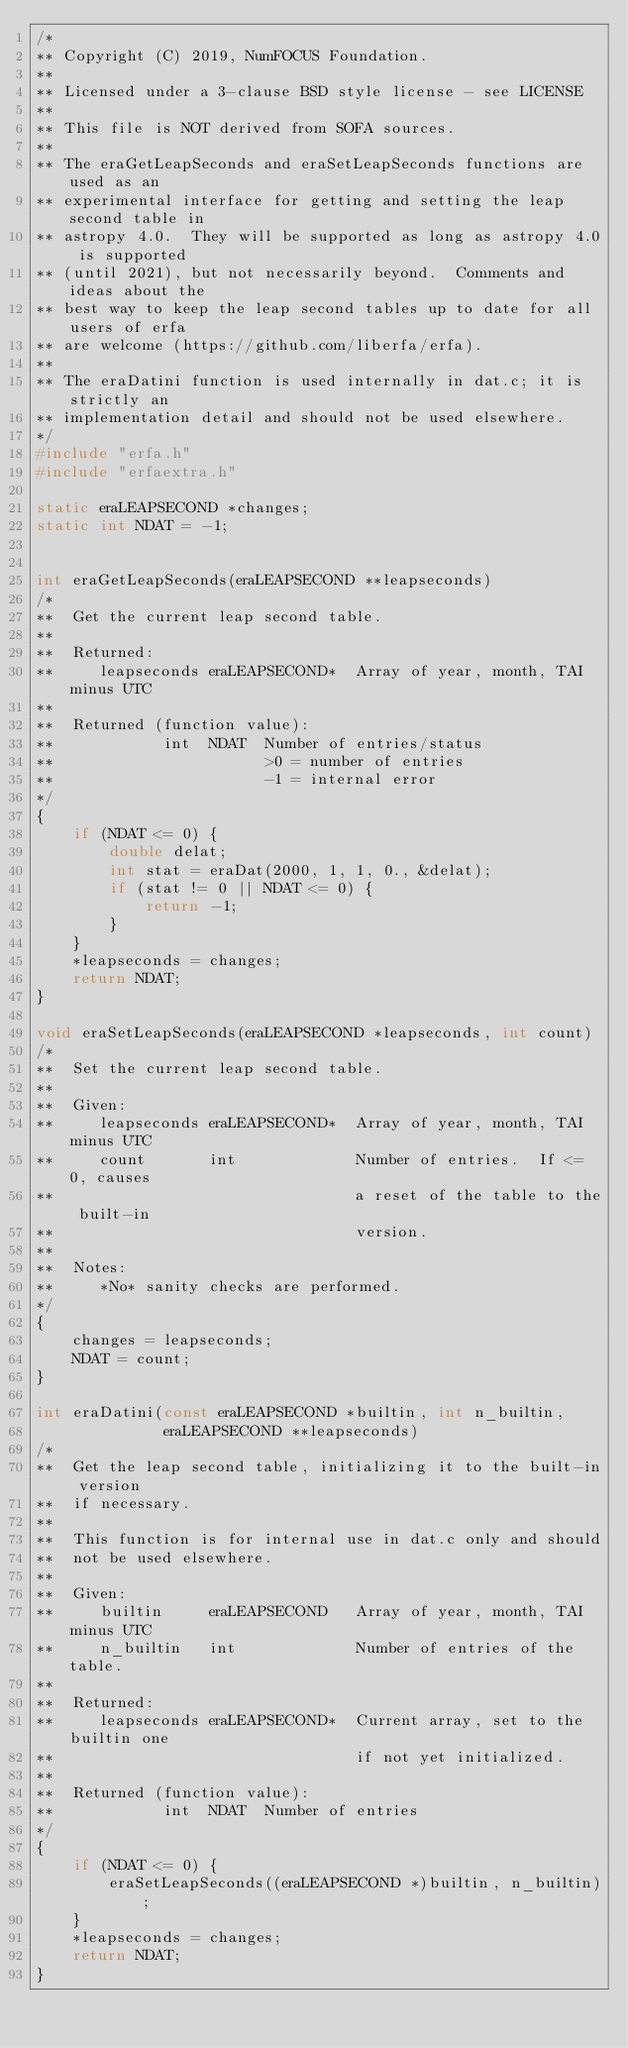Convert code to text. <code><loc_0><loc_0><loc_500><loc_500><_C_>/*
** Copyright (C) 2019, NumFOCUS Foundation.
**
** Licensed under a 3-clause BSD style license - see LICENSE
**
** This file is NOT derived from SOFA sources.
**
** The eraGetLeapSeconds and eraSetLeapSeconds functions are used as an
** experimental interface for getting and setting the leap second table in
** astropy 4.0.  They will be supported as long as astropy 4.0 is supported
** (until 2021), but not necessarily beyond.  Comments and ideas about the
** best way to keep the leap second tables up to date for all users of erfa
** are welcome (https://github.com/liberfa/erfa).
**
** The eraDatini function is used internally in dat.c; it is strictly an
** implementation detail and should not be used elsewhere.
*/
#include "erfa.h"
#include "erfaextra.h"

static eraLEAPSECOND *changes;
static int NDAT = -1;


int eraGetLeapSeconds(eraLEAPSECOND **leapseconds)
/*
**  Get the current leap second table.
**
**  Returned:
**     leapseconds eraLEAPSECOND*  Array of year, month, TAI minus UTC
**
**  Returned (function value):
**            int  NDAT  Number of entries/status
**                       >0 = number of entries
**                       -1 = internal error
*/
{
    if (NDAT <= 0) {
        double delat;
        int stat = eraDat(2000, 1, 1, 0., &delat);
        if (stat != 0 || NDAT <= 0) {
            return -1;
        }
    }
    *leapseconds = changes;
    return NDAT;
}

void eraSetLeapSeconds(eraLEAPSECOND *leapseconds, int count)
/*
**  Set the current leap second table.
**
**  Given:
**     leapseconds eraLEAPSECOND*  Array of year, month, TAI minus UTC
**     count       int             Number of entries.  If <= 0, causes
**                                 a reset of the table to the built-in
**                                 version.
**
**  Notes:
**     *No* sanity checks are performed.
*/
{
    changes = leapseconds;
    NDAT = count;
}

int eraDatini(const eraLEAPSECOND *builtin, int n_builtin,
              eraLEAPSECOND **leapseconds)
/*
**  Get the leap second table, initializing it to the built-in version
**  if necessary.
**
**  This function is for internal use in dat.c only and should
**  not be used elsewhere.
**
**  Given:
**     builtin     eraLEAPSECOND   Array of year, month, TAI minus UTC
**     n_builtin   int             Number of entries of the table.
**
**  Returned:
**     leapseconds eraLEAPSECOND*  Current array, set to the builtin one
**                                 if not yet initialized.
**
**  Returned (function value):
**            int  NDAT  Number of entries
*/
{
    if (NDAT <= 0) {
        eraSetLeapSeconds((eraLEAPSECOND *)builtin, n_builtin);
    }
    *leapseconds = changes;
    return NDAT;
}
</code> 